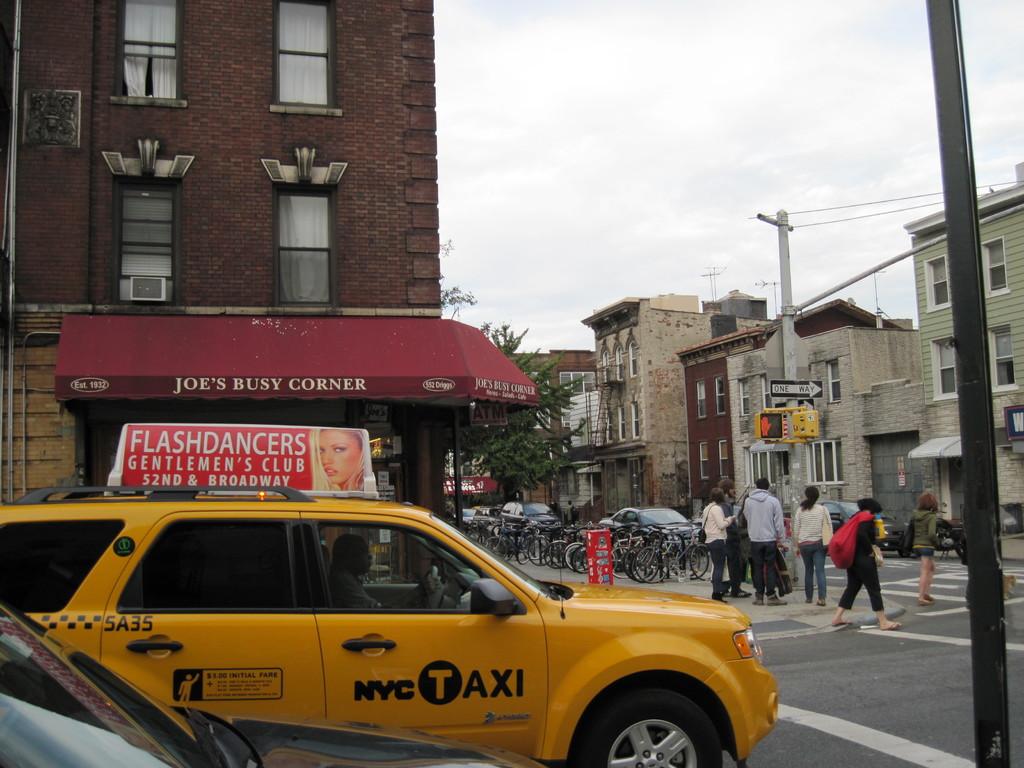Where is the company being advertised on the taxi?
Give a very brief answer. Roof. 